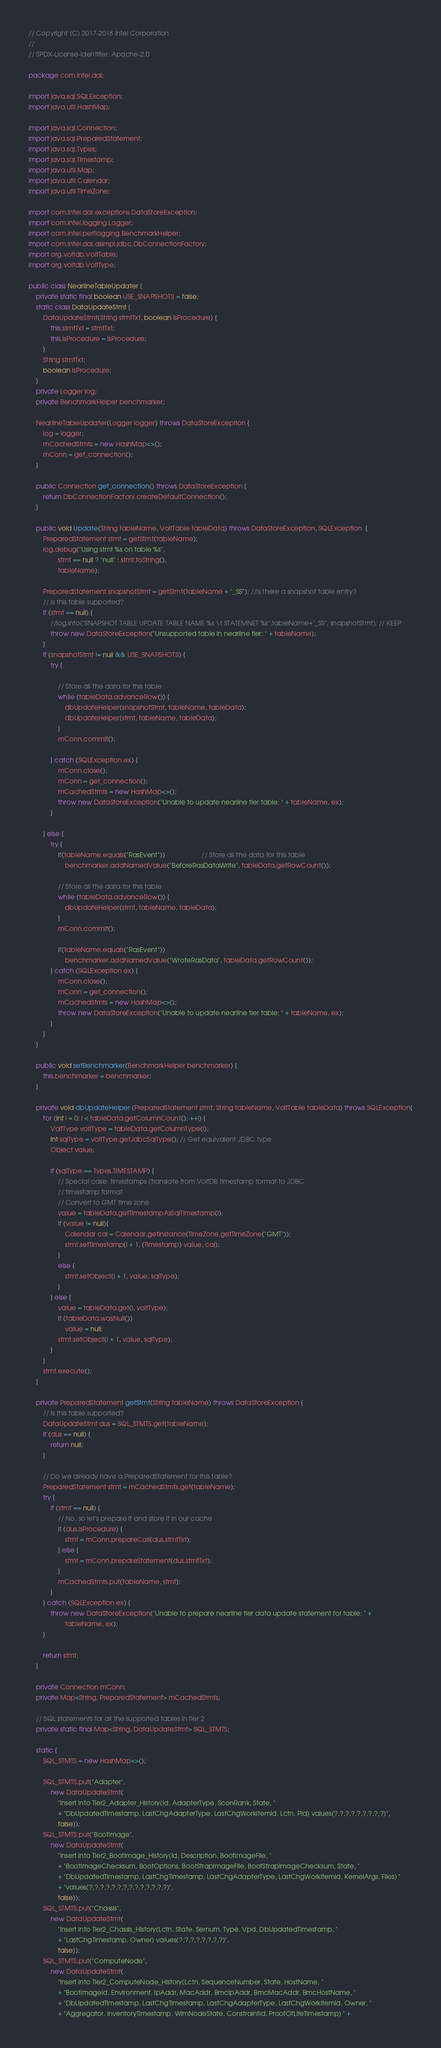Convert code to text. <code><loc_0><loc_0><loc_500><loc_500><_Java_>// Copyright (C) 2017-2018 Intel Corporation
//
// SPDX-License-Identifier: Apache-2.0

package com.intel.dai;

import java.sql.SQLException;
import java.util.HashMap;

import java.sql.Connection;
import java.sql.PreparedStatement;
import java.sql.Types;
import java.sql.Timestamp;
import java.util.Map;
import java.util.Calendar;
import java.util.TimeZone;

import com.intel.dai.exceptions.DataStoreException;
import com.intel.logging.Logger;
import com.intel.perflogging.BenchmarkHelper;
import com.intel.dai.dsimpl.jdbc.DbConnectionFactory;
import org.voltdb.VoltTable;
import org.voltdb.VoltType;

public class NearlineTableUpdater {
    private static final boolean USE_SNAPSHOTS = false;
    static class DataUpdateStmt {
        DataUpdateStmt(String stmtTxt, boolean isProcedure) {
            this.stmtTxt = stmtTxt;
            this.isProcedure = isProcedure;
        }
        String stmtTxt;
        boolean isProcedure;
    }
    private Logger log;
    private BenchmarkHelper benchmarker;

    NearlineTableUpdater(Logger logger) throws DataStoreException {
        log = logger;
        mCachedStmts = new HashMap<>();
        mConn = get_connection();
    }

    public Connection get_connection() throws DataStoreException {
        return DbConnectionFactory.createDefaultConnection();
    }

    public void Update(String tableName, VoltTable tableData) throws DataStoreException, SQLException  {
        PreparedStatement stmt = getStmt(tableName);
        log.debug("Using stmt %s on table %s",
                stmt == null ? "null" : stmt.toString(),
                tableName);

        PreparedStatement snapshotStmt = getStmt(tableName + "_SS"); //Is there a snapshot table entry?
        // Is this table supported?
        if (stmt == null) {
            //log.info("SNAPSHOT TABLE UPDATE TABLE NAME %s \t STATEMNET %s",tableName+"_SS", snapshotStmt); // KEEP
            throw new DataStoreException("Unsupported table in nearline tier: " + tableName);
        }
        if (snapshotStmt != null && USE_SNAPSHOTS) {
            try {

                // Store all the data for this table
                while (tableData.advanceRow()) {
                    dbUpdateHelper(snapshotStmt, tableName, tableData);
                    dbUpdateHelper(stmt, tableName, tableData);
                }
                mConn.commit();

            } catch (SQLException ex) {
                mConn.close();
                mConn = get_connection();
                mCachedStmts = new HashMap<>();
                throw new DataStoreException("Unable to update nearline tier table: " + tableName, ex);
            }

        } else {
            try {
                if(tableName.equals("RasEvent"))	                // Store all the data for this table
                    benchmarker.addNamedValue("BeforeRasDataWrite", tableData.getRowCount());

                // Store all the data for this table
                while (tableData.advanceRow()) {
                    dbUpdateHelper(stmt, tableName, tableData);
                }
                mConn.commit();

                if(tableName.equals("RasEvent"))
                    benchmarker.addNamedValue("WroteRasData", tableData.getRowCount());
            } catch (SQLException ex) {
                mConn.close();
                mConn = get_connection();
                mCachedStmts = new HashMap<>();
                throw new DataStoreException("Unable to update nearline tier table: " + tableName, ex);
            }
        }
    }

    public void setBenchmarker(BenchmarkHelper benchmarker) {
        this.benchmarker = benchmarker;
    }

    private void dbUpdateHelper (PreparedStatement stmt, String tableName, VoltTable tableData) throws SQLException{
        for (int i = 0; i < tableData.getColumnCount(); ++i) {
            VoltType voltType = tableData.getColumnType(i);
            int sqlType = voltType.getJdbcSqlType(); // Get equivalent JDBC type
            Object value;

            if (sqlType == Types.TIMESTAMP) {
                // Special case: timestamps (translate from VoltDB timestamp format to JDBC
                // timestamp format
                // Convert to GMT time zone
                value = tableData.getTimestampAsSqlTimestamp(i);
                if (value != null){
                    Calendar cal = Calendar.getInstance(TimeZone.getTimeZone("GMT"));
                    stmt.setTimestamp(i + 1, (Timestamp) value, cal);
                }
                else {
                    stmt.setObject(i + 1, value, sqlType);
                }
            } else {
                value = tableData.get(i, voltType);
                if (tableData.wasNull())
                    value = null;
                stmt.setObject(i + 1, value, sqlType);
            }
        }
        stmt.execute();
    }

    private PreparedStatement getStmt(String tableName) throws DataStoreException {
        // Is this table supported?
        DataUpdateStmt dus = SQL_STMTS.get(tableName);
        if (dus == null) {
            return null;
        }

        // Do we already have a PreparedStatement for this table?
        PreparedStatement stmt = mCachedStmts.get(tableName);
        try {
            if (stmt == null) {
                // No, so let's prepare it and store it in our cache
                if (dus.isProcedure) {
                    stmt = mConn.prepareCall(dus.stmtTxt);
                } else {
                    stmt = mConn.prepareStatement(dus.stmtTxt);
                }
                mCachedStmts.put(tableName, stmt);
            }
        } catch (SQLException ex) {
            throw new DataStoreException("Unable to prepare nearline tier data update statement for table: " +
                    tableName, ex);
        }

        return stmt;
    }

    private Connection mConn;
    private Map<String, PreparedStatement> mCachedStmts;

    // SQL statements for all the supported tables in tier 2
    private static final Map<String, DataUpdateStmt> SQL_STMTS;

    static {
        SQL_STMTS = new HashMap<>();

        SQL_STMTS.put("Adapter",
            new DataUpdateStmt(
                "insert into Tier2_Adapter_History(Id, AdapterType, SconRank, State, "
                + "DbUpdatedTimestamp, LastChgAdapterType, LastChgWorkItemId, Lctn, Pid) values(?,?,?,?,?,?,?,?,?)",
                false));
        SQL_STMTS.put("BootImage",
            new DataUpdateStmt(
                "insert into Tier2_BootImage_History(Id, Description, BootImageFile, "
                + "BootImageChecksum, BootOptions, BootStrapImageFile, BootStrapImageChecksum, State, "
                + "DbUpdatedTimestamp, LastChgTimestamp, LastChgAdapterType, LastChgWorkItemId, KernelArgs, Files) "
                + "values(?,?,?,?,?,?,?,?,?,?,?,?,?,?)",
                false));
        SQL_STMTS.put("Chassis",
            new DataUpdateStmt(
                "insert into Tier2_Chassis_History(Lctn, State, Sernum, Type, Vpd, DbUpdatedTimestamp, "
                + "LastChgTimestamp, Owner) values(?,?,?,?,?,?,?,?)",
                false));
        SQL_STMTS.put("ComputeNode",
            new DataUpdateStmt(
                "insert into Tier2_ComputeNode_History(Lctn, SequenceNumber, State, HostName, "
                + "BootImageId, Environment, IpAddr, MacAddr, BmcIpAddr, BmcMacAddr, BmcHostName, "
                + "DbUpdatedTimestamp, LastChgTimestamp, LastChgAdapterType, LastChgWorkItemId, Owner, "
                + "Aggregator, InventoryTimestamp, WlmNodeState, ConstraintId, ProofOfLifeTimestamp) " +</code> 